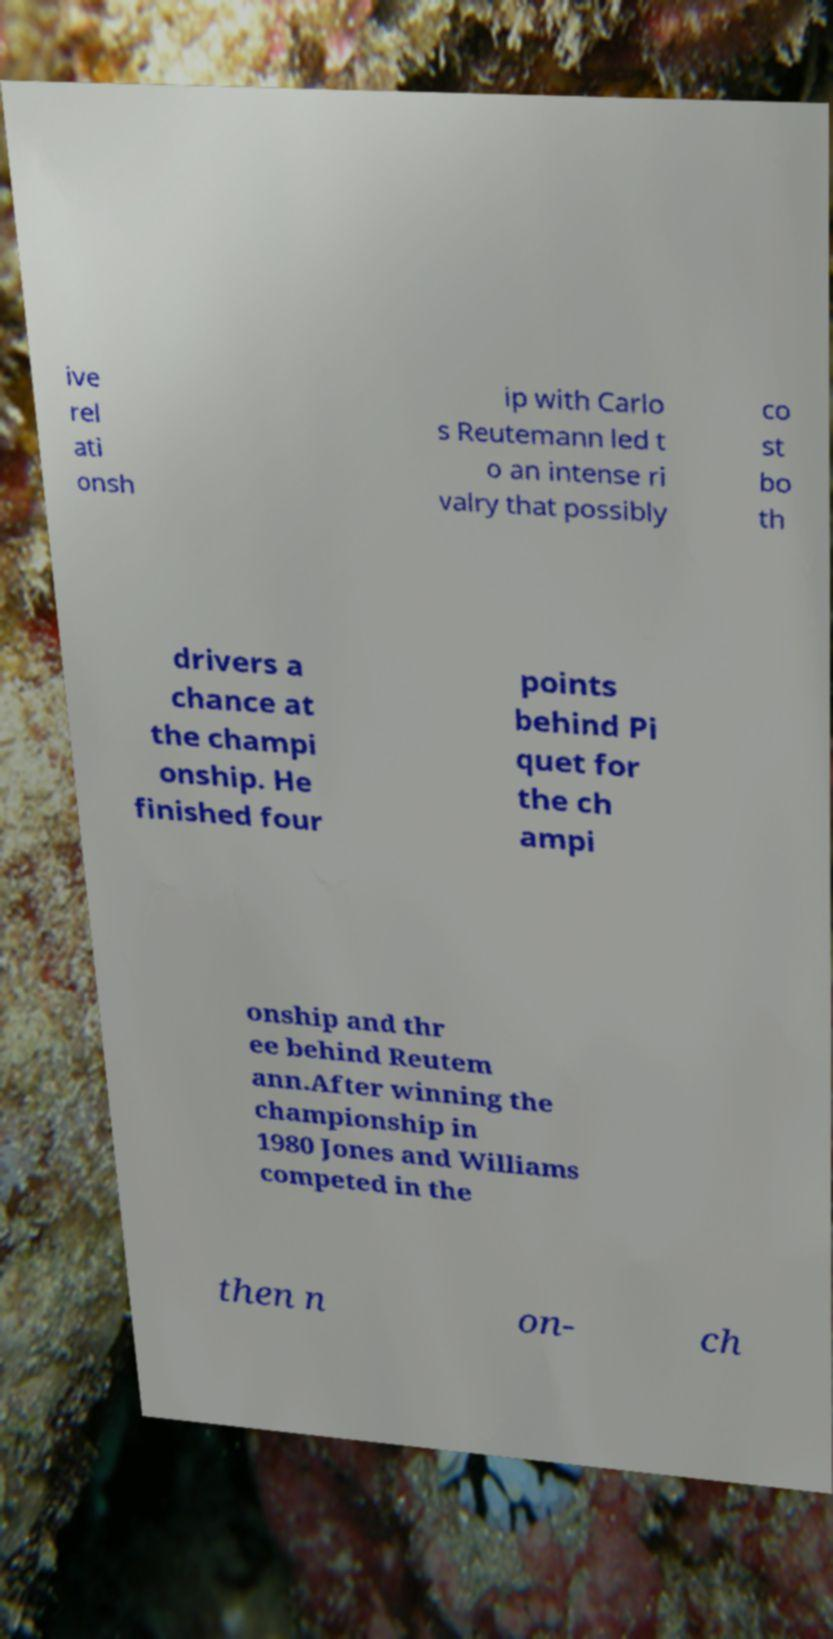Please read and relay the text visible in this image. What does it say? ive rel ati onsh ip with Carlo s Reutemann led t o an intense ri valry that possibly co st bo th drivers a chance at the champi onship. He finished four points behind Pi quet for the ch ampi onship and thr ee behind Reutem ann.After winning the championship in 1980 Jones and Williams competed in the then n on- ch 